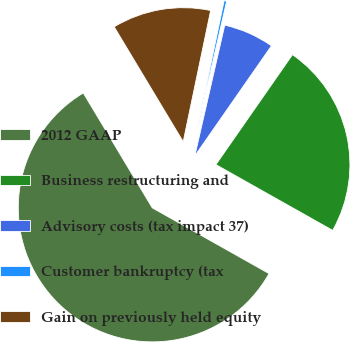Convert chart. <chart><loc_0><loc_0><loc_500><loc_500><pie_chart><fcel>2012 GAAP<fcel>Business restructuring and<fcel>Advisory costs (tax impact 37)<fcel>Customer bankruptcy (tax<fcel>Gain on previously held equity<nl><fcel>58.23%<fcel>23.48%<fcel>6.1%<fcel>0.3%<fcel>11.89%<nl></chart> 